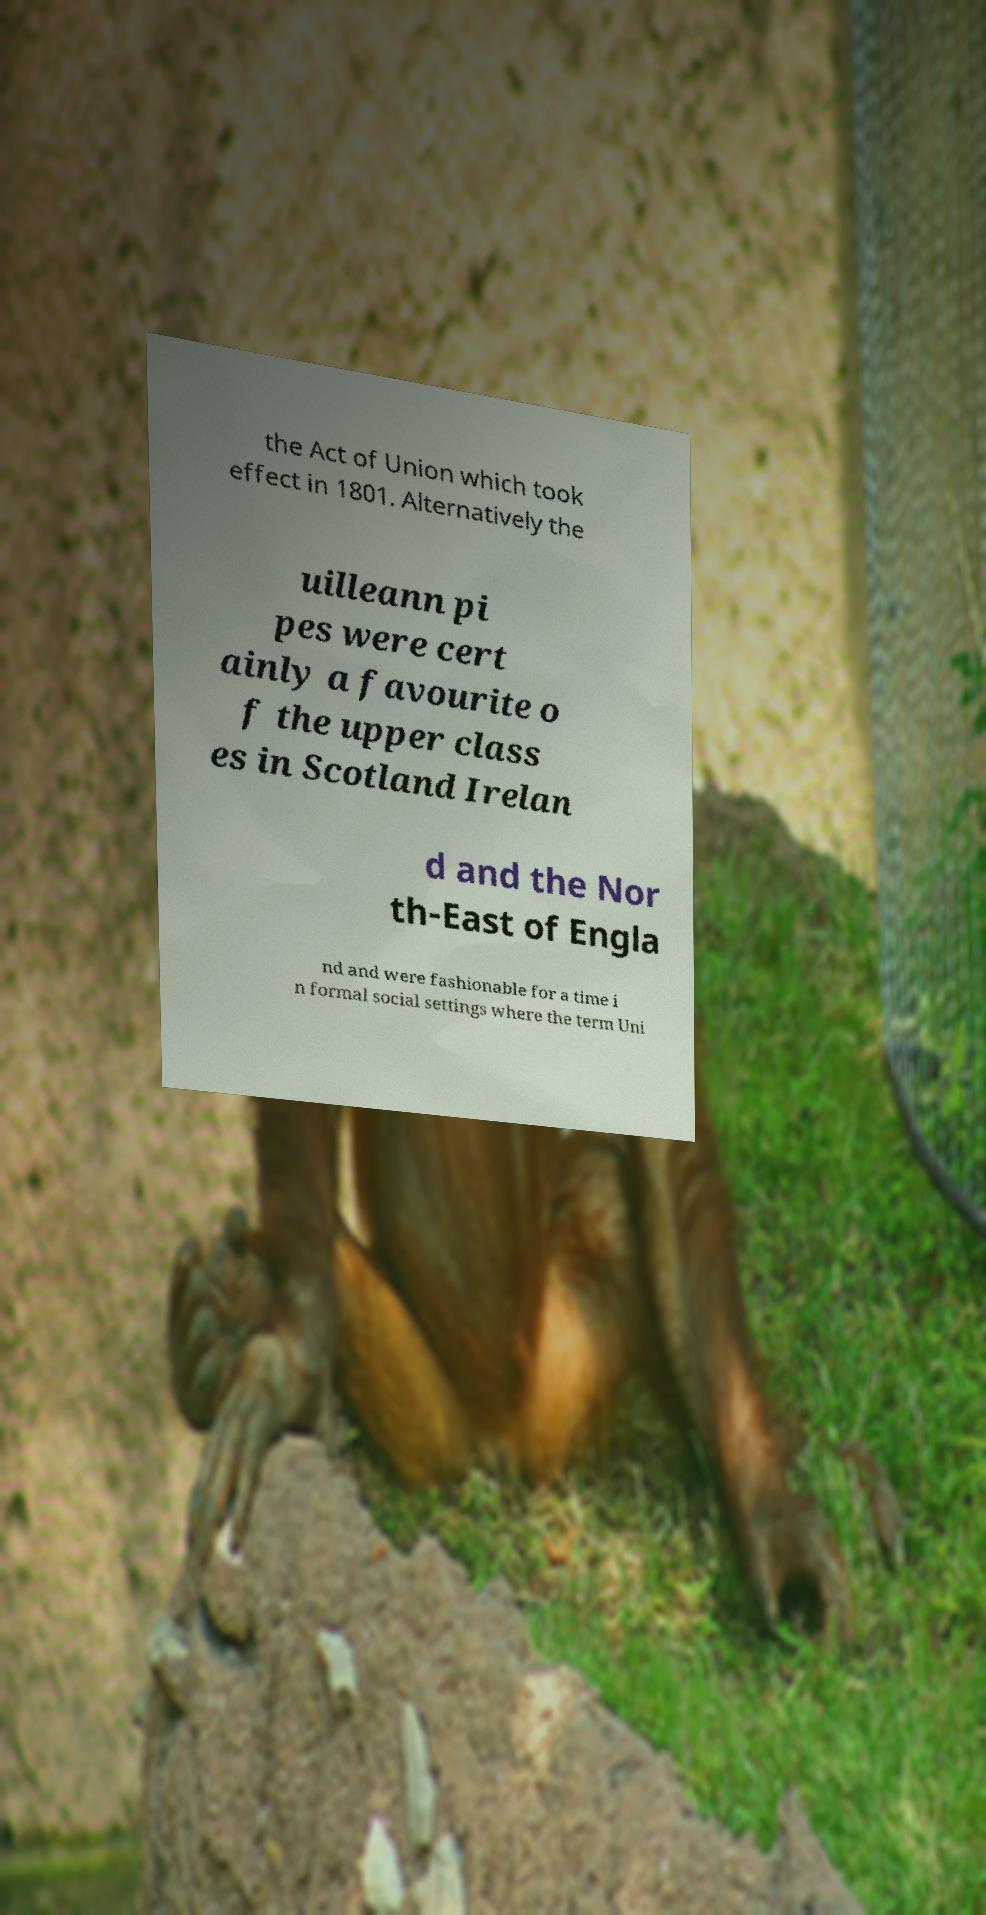Can you accurately transcribe the text from the provided image for me? the Act of Union which took effect in 1801. Alternatively the uilleann pi pes were cert ainly a favourite o f the upper class es in Scotland Irelan d and the Nor th-East of Engla nd and were fashionable for a time i n formal social settings where the term Uni 